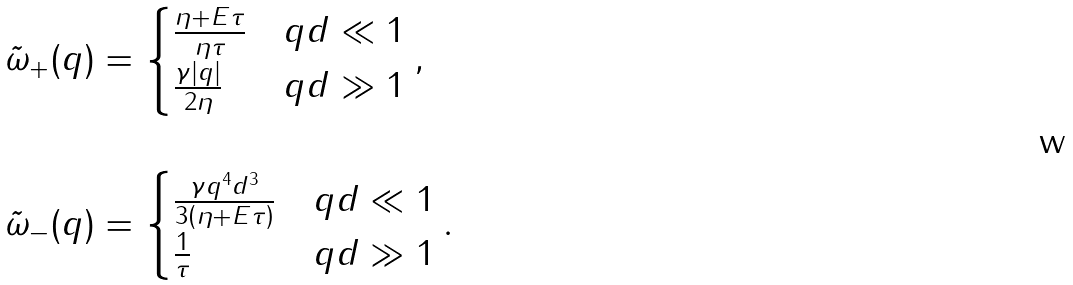<formula> <loc_0><loc_0><loc_500><loc_500>\tilde { \omega } _ { + } ( q ) & = \begin{cases} \frac { \eta + E \tau } { \eta \tau } & q d \ll 1 \\ \frac { \gamma | q | } { 2 \eta } & q d \gg 1 \end{cases} , \\ \\ \tilde { \omega } _ { - } ( q ) & = \begin{cases} \frac { \gamma q ^ { 4 } d ^ { 3 } } { 3 \left ( \eta + E \tau \right ) } & q d \ll 1 \\ \frac { 1 } { \tau } & q d \gg 1 \end{cases} .</formula> 